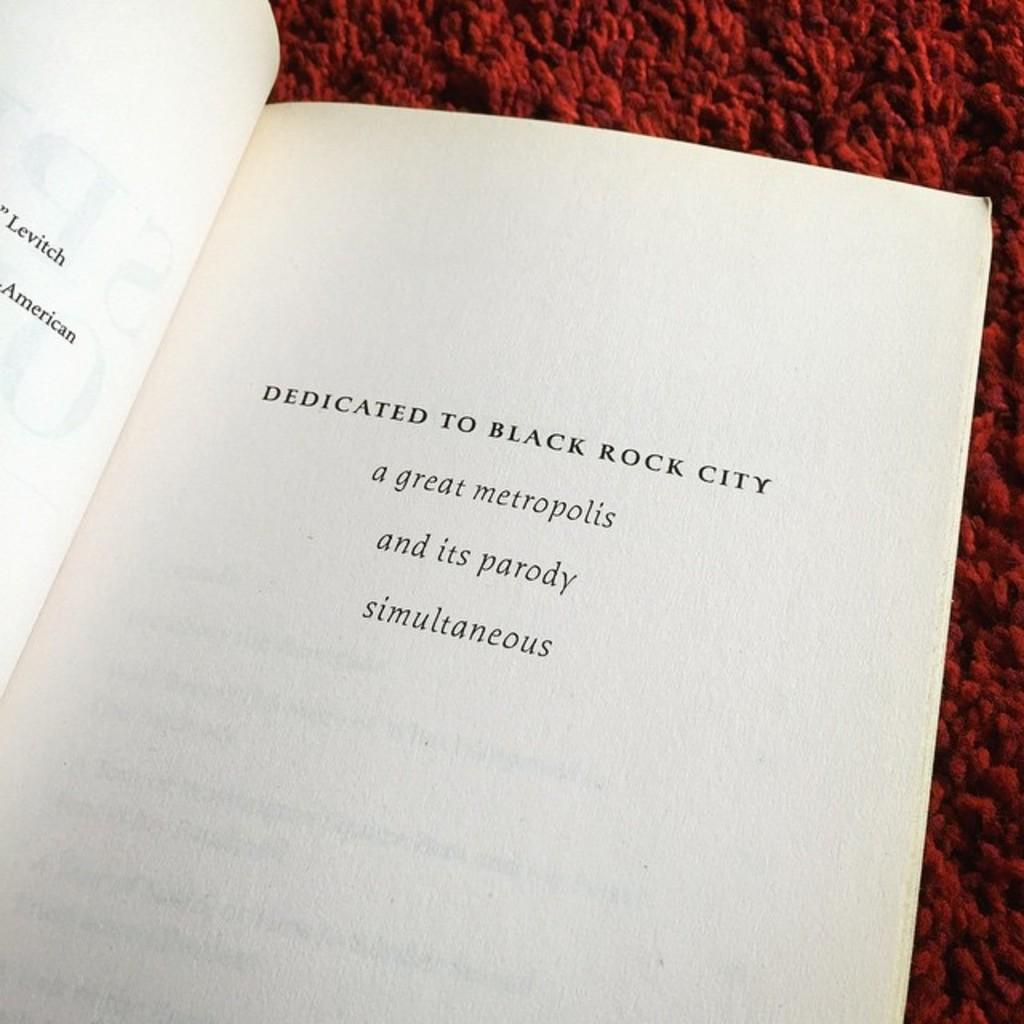Provide a one-sentence caption for the provided image. opened book that is dedicated to black rock city. 